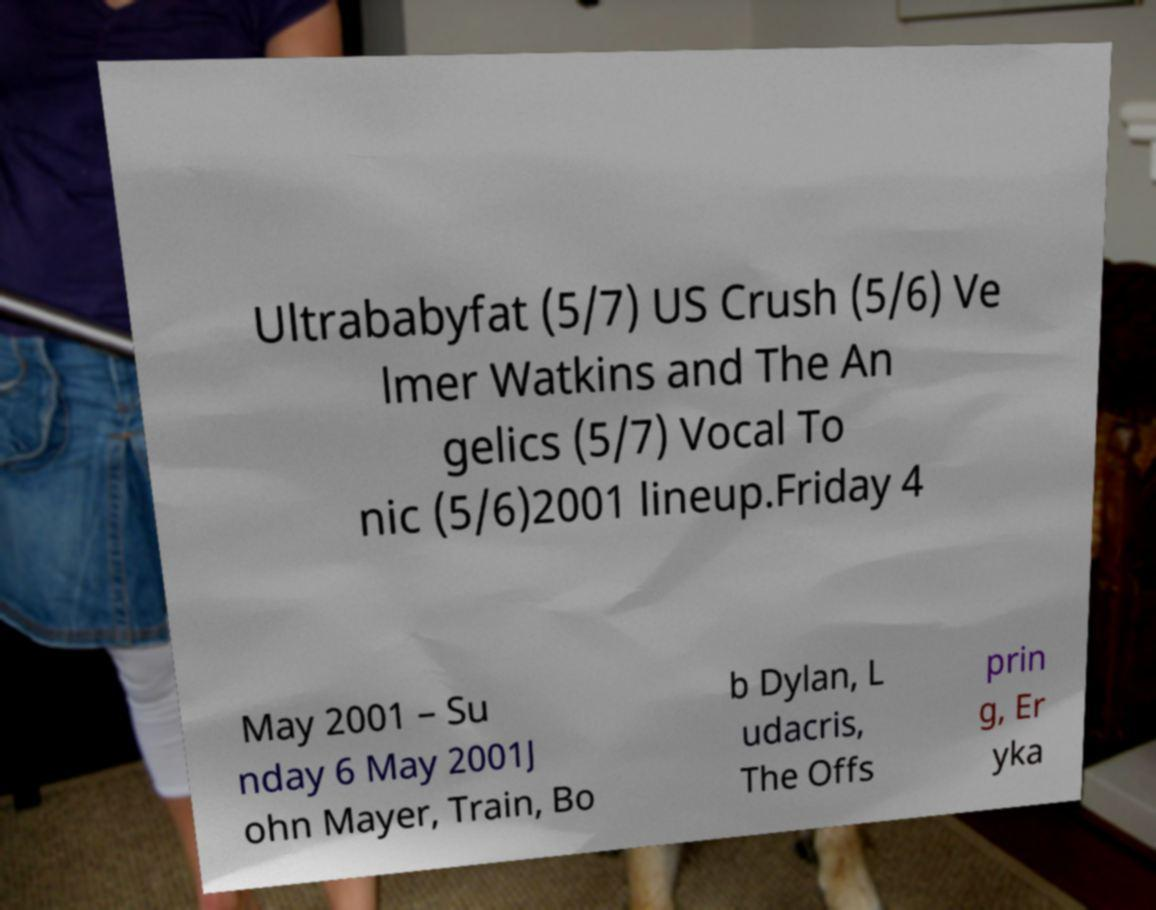Please read and relay the text visible in this image. What does it say? Ultrababyfat (5/7) US Crush (5/6) Ve lmer Watkins and The An gelics (5/7) Vocal To nic (5/6)2001 lineup.Friday 4 May 2001 – Su nday 6 May 2001J ohn Mayer, Train, Bo b Dylan, L udacris, The Offs prin g, Er yka 